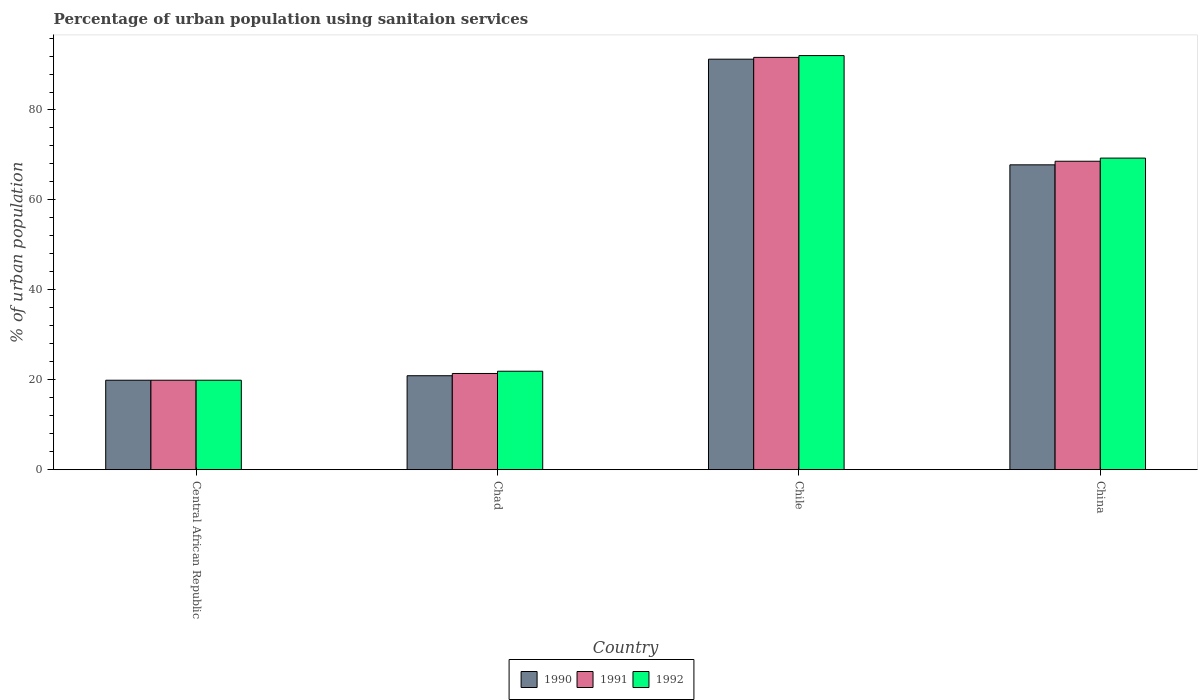How many different coloured bars are there?
Provide a short and direct response. 3. Are the number of bars on each tick of the X-axis equal?
Your answer should be very brief. Yes. What is the label of the 1st group of bars from the left?
Provide a short and direct response. Central African Republic. What is the percentage of urban population using sanitaion services in 1991 in Chad?
Your response must be concise. 21.4. Across all countries, what is the maximum percentage of urban population using sanitaion services in 1990?
Keep it short and to the point. 91.3. In which country was the percentage of urban population using sanitaion services in 1991 minimum?
Your answer should be very brief. Central African Republic. What is the total percentage of urban population using sanitaion services in 1990 in the graph?
Provide a succinct answer. 199.9. What is the difference between the percentage of urban population using sanitaion services in 1992 in Chile and that in China?
Give a very brief answer. 22.8. What is the difference between the percentage of urban population using sanitaion services in 1991 in Central African Republic and the percentage of urban population using sanitaion services in 1990 in China?
Make the answer very short. -47.9. What is the average percentage of urban population using sanitaion services in 1990 per country?
Offer a terse response. 49.97. What is the difference between the percentage of urban population using sanitaion services of/in 1992 and percentage of urban population using sanitaion services of/in 1991 in Chad?
Your answer should be very brief. 0.5. What is the ratio of the percentage of urban population using sanitaion services in 1991 in Chad to that in Chile?
Your answer should be compact. 0.23. What is the difference between the highest and the second highest percentage of urban population using sanitaion services in 1991?
Ensure brevity in your answer.  23.1. What is the difference between the highest and the lowest percentage of urban population using sanitaion services in 1991?
Your answer should be compact. 71.8. In how many countries, is the percentage of urban population using sanitaion services in 1990 greater than the average percentage of urban population using sanitaion services in 1990 taken over all countries?
Make the answer very short. 2. Is the sum of the percentage of urban population using sanitaion services in 1991 in Central African Republic and China greater than the maximum percentage of urban population using sanitaion services in 1990 across all countries?
Make the answer very short. No. What does the 3rd bar from the left in Chile represents?
Your answer should be compact. 1992. What does the 2nd bar from the right in Chile represents?
Offer a very short reply. 1991. Are all the bars in the graph horizontal?
Offer a very short reply. No. How many countries are there in the graph?
Keep it short and to the point. 4. Are the values on the major ticks of Y-axis written in scientific E-notation?
Your answer should be compact. No. Does the graph contain any zero values?
Provide a short and direct response. No. Does the graph contain grids?
Offer a terse response. No. Where does the legend appear in the graph?
Your response must be concise. Bottom center. What is the title of the graph?
Offer a very short reply. Percentage of urban population using sanitaion services. Does "1995" appear as one of the legend labels in the graph?
Provide a short and direct response. No. What is the label or title of the Y-axis?
Provide a succinct answer. % of urban population. What is the % of urban population in 1992 in Central African Republic?
Provide a succinct answer. 19.9. What is the % of urban population of 1990 in Chad?
Your answer should be very brief. 20.9. What is the % of urban population of 1991 in Chad?
Ensure brevity in your answer.  21.4. What is the % of urban population of 1992 in Chad?
Keep it short and to the point. 21.9. What is the % of urban population of 1990 in Chile?
Ensure brevity in your answer.  91.3. What is the % of urban population of 1991 in Chile?
Your answer should be very brief. 91.7. What is the % of urban population in 1992 in Chile?
Your answer should be very brief. 92.1. What is the % of urban population of 1990 in China?
Provide a succinct answer. 67.8. What is the % of urban population of 1991 in China?
Keep it short and to the point. 68.6. What is the % of urban population of 1992 in China?
Your answer should be very brief. 69.3. Across all countries, what is the maximum % of urban population in 1990?
Offer a terse response. 91.3. Across all countries, what is the maximum % of urban population in 1991?
Offer a terse response. 91.7. Across all countries, what is the maximum % of urban population in 1992?
Provide a succinct answer. 92.1. Across all countries, what is the minimum % of urban population in 1990?
Give a very brief answer. 19.9. Across all countries, what is the minimum % of urban population of 1991?
Give a very brief answer. 19.9. Across all countries, what is the minimum % of urban population of 1992?
Offer a very short reply. 19.9. What is the total % of urban population in 1990 in the graph?
Give a very brief answer. 199.9. What is the total % of urban population of 1991 in the graph?
Provide a short and direct response. 201.6. What is the total % of urban population of 1992 in the graph?
Provide a succinct answer. 203.2. What is the difference between the % of urban population in 1991 in Central African Republic and that in Chad?
Keep it short and to the point. -1.5. What is the difference between the % of urban population in 1990 in Central African Republic and that in Chile?
Give a very brief answer. -71.4. What is the difference between the % of urban population of 1991 in Central African Republic and that in Chile?
Your answer should be compact. -71.8. What is the difference between the % of urban population in 1992 in Central African Republic and that in Chile?
Provide a succinct answer. -72.2. What is the difference between the % of urban population of 1990 in Central African Republic and that in China?
Ensure brevity in your answer.  -47.9. What is the difference between the % of urban population of 1991 in Central African Republic and that in China?
Provide a short and direct response. -48.7. What is the difference between the % of urban population of 1992 in Central African Republic and that in China?
Give a very brief answer. -49.4. What is the difference between the % of urban population of 1990 in Chad and that in Chile?
Your answer should be compact. -70.4. What is the difference between the % of urban population in 1991 in Chad and that in Chile?
Give a very brief answer. -70.3. What is the difference between the % of urban population in 1992 in Chad and that in Chile?
Your response must be concise. -70.2. What is the difference between the % of urban population in 1990 in Chad and that in China?
Provide a succinct answer. -46.9. What is the difference between the % of urban population of 1991 in Chad and that in China?
Offer a very short reply. -47.2. What is the difference between the % of urban population of 1992 in Chad and that in China?
Give a very brief answer. -47.4. What is the difference between the % of urban population in 1990 in Chile and that in China?
Offer a terse response. 23.5. What is the difference between the % of urban population in 1991 in Chile and that in China?
Your answer should be compact. 23.1. What is the difference between the % of urban population in 1992 in Chile and that in China?
Your answer should be compact. 22.8. What is the difference between the % of urban population in 1990 in Central African Republic and the % of urban population in 1991 in Chad?
Keep it short and to the point. -1.5. What is the difference between the % of urban population of 1990 in Central African Republic and the % of urban population of 1991 in Chile?
Provide a succinct answer. -71.8. What is the difference between the % of urban population in 1990 in Central African Republic and the % of urban population in 1992 in Chile?
Offer a terse response. -72.2. What is the difference between the % of urban population of 1991 in Central African Republic and the % of urban population of 1992 in Chile?
Your answer should be compact. -72.2. What is the difference between the % of urban population of 1990 in Central African Republic and the % of urban population of 1991 in China?
Your response must be concise. -48.7. What is the difference between the % of urban population in 1990 in Central African Republic and the % of urban population in 1992 in China?
Keep it short and to the point. -49.4. What is the difference between the % of urban population in 1991 in Central African Republic and the % of urban population in 1992 in China?
Your response must be concise. -49.4. What is the difference between the % of urban population in 1990 in Chad and the % of urban population in 1991 in Chile?
Your answer should be compact. -70.8. What is the difference between the % of urban population in 1990 in Chad and the % of urban population in 1992 in Chile?
Provide a short and direct response. -71.2. What is the difference between the % of urban population of 1991 in Chad and the % of urban population of 1992 in Chile?
Offer a very short reply. -70.7. What is the difference between the % of urban population in 1990 in Chad and the % of urban population in 1991 in China?
Give a very brief answer. -47.7. What is the difference between the % of urban population in 1990 in Chad and the % of urban population in 1992 in China?
Keep it short and to the point. -48.4. What is the difference between the % of urban population of 1991 in Chad and the % of urban population of 1992 in China?
Provide a short and direct response. -47.9. What is the difference between the % of urban population of 1990 in Chile and the % of urban population of 1991 in China?
Give a very brief answer. 22.7. What is the difference between the % of urban population of 1991 in Chile and the % of urban population of 1992 in China?
Give a very brief answer. 22.4. What is the average % of urban population in 1990 per country?
Ensure brevity in your answer.  49.98. What is the average % of urban population in 1991 per country?
Your answer should be very brief. 50.4. What is the average % of urban population in 1992 per country?
Your response must be concise. 50.8. What is the difference between the % of urban population of 1990 and % of urban population of 1991 in Central African Republic?
Your response must be concise. 0. What is the difference between the % of urban population of 1991 and % of urban population of 1992 in Central African Republic?
Your response must be concise. 0. What is the difference between the % of urban population of 1991 and % of urban population of 1992 in Chad?
Make the answer very short. -0.5. What is the difference between the % of urban population of 1990 and % of urban population of 1991 in China?
Ensure brevity in your answer.  -0.8. What is the ratio of the % of urban population of 1990 in Central African Republic to that in Chad?
Make the answer very short. 0.95. What is the ratio of the % of urban population of 1991 in Central African Republic to that in Chad?
Make the answer very short. 0.93. What is the ratio of the % of urban population of 1992 in Central African Republic to that in Chad?
Your answer should be very brief. 0.91. What is the ratio of the % of urban population of 1990 in Central African Republic to that in Chile?
Make the answer very short. 0.22. What is the ratio of the % of urban population of 1991 in Central African Republic to that in Chile?
Ensure brevity in your answer.  0.22. What is the ratio of the % of urban population of 1992 in Central African Republic to that in Chile?
Provide a short and direct response. 0.22. What is the ratio of the % of urban population of 1990 in Central African Republic to that in China?
Your answer should be compact. 0.29. What is the ratio of the % of urban population in 1991 in Central African Republic to that in China?
Keep it short and to the point. 0.29. What is the ratio of the % of urban population of 1992 in Central African Republic to that in China?
Ensure brevity in your answer.  0.29. What is the ratio of the % of urban population of 1990 in Chad to that in Chile?
Give a very brief answer. 0.23. What is the ratio of the % of urban population in 1991 in Chad to that in Chile?
Your response must be concise. 0.23. What is the ratio of the % of urban population in 1992 in Chad to that in Chile?
Provide a short and direct response. 0.24. What is the ratio of the % of urban population in 1990 in Chad to that in China?
Your response must be concise. 0.31. What is the ratio of the % of urban population of 1991 in Chad to that in China?
Your answer should be very brief. 0.31. What is the ratio of the % of urban population in 1992 in Chad to that in China?
Your answer should be compact. 0.32. What is the ratio of the % of urban population of 1990 in Chile to that in China?
Offer a terse response. 1.35. What is the ratio of the % of urban population in 1991 in Chile to that in China?
Keep it short and to the point. 1.34. What is the ratio of the % of urban population in 1992 in Chile to that in China?
Ensure brevity in your answer.  1.33. What is the difference between the highest and the second highest % of urban population in 1991?
Your answer should be compact. 23.1. What is the difference between the highest and the second highest % of urban population in 1992?
Provide a succinct answer. 22.8. What is the difference between the highest and the lowest % of urban population of 1990?
Keep it short and to the point. 71.4. What is the difference between the highest and the lowest % of urban population of 1991?
Make the answer very short. 71.8. What is the difference between the highest and the lowest % of urban population in 1992?
Offer a very short reply. 72.2. 